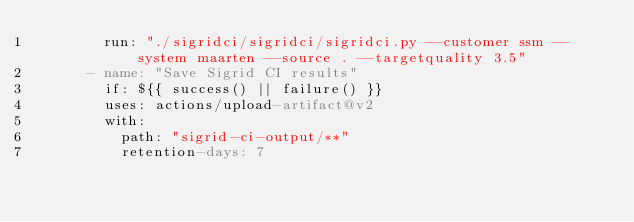<code> <loc_0><loc_0><loc_500><loc_500><_YAML_>        run: "./sigridci/sigridci/sigridci.py --customer ssm --system maarten --source . --targetquality 3.5"
      - name: "Save Sigrid CI results"
        if: ${{ success() || failure() }}
        uses: actions/upload-artifact@v2
        with:
          path: "sigrid-ci-output/**"
          retention-days: 7
</code> 